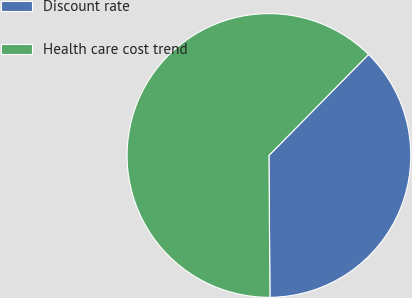Convert chart. <chart><loc_0><loc_0><loc_500><loc_500><pie_chart><fcel>Discount rate<fcel>Health care cost trend<nl><fcel>37.5%<fcel>62.5%<nl></chart> 